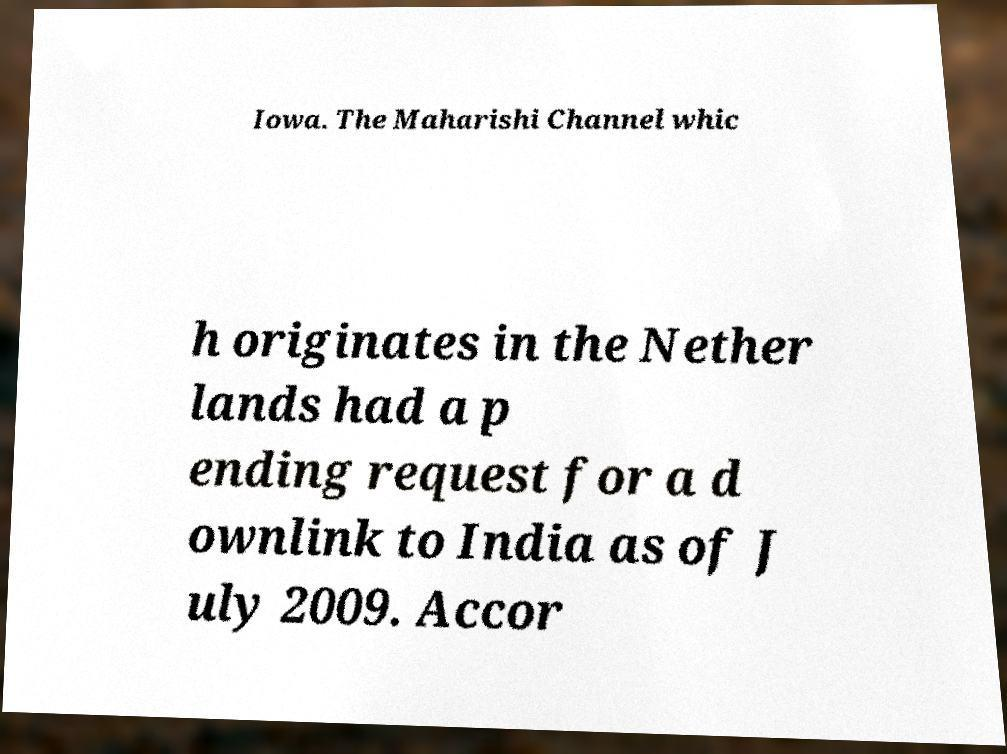For documentation purposes, I need the text within this image transcribed. Could you provide that? Iowa. The Maharishi Channel whic h originates in the Nether lands had a p ending request for a d ownlink to India as of J uly 2009. Accor 